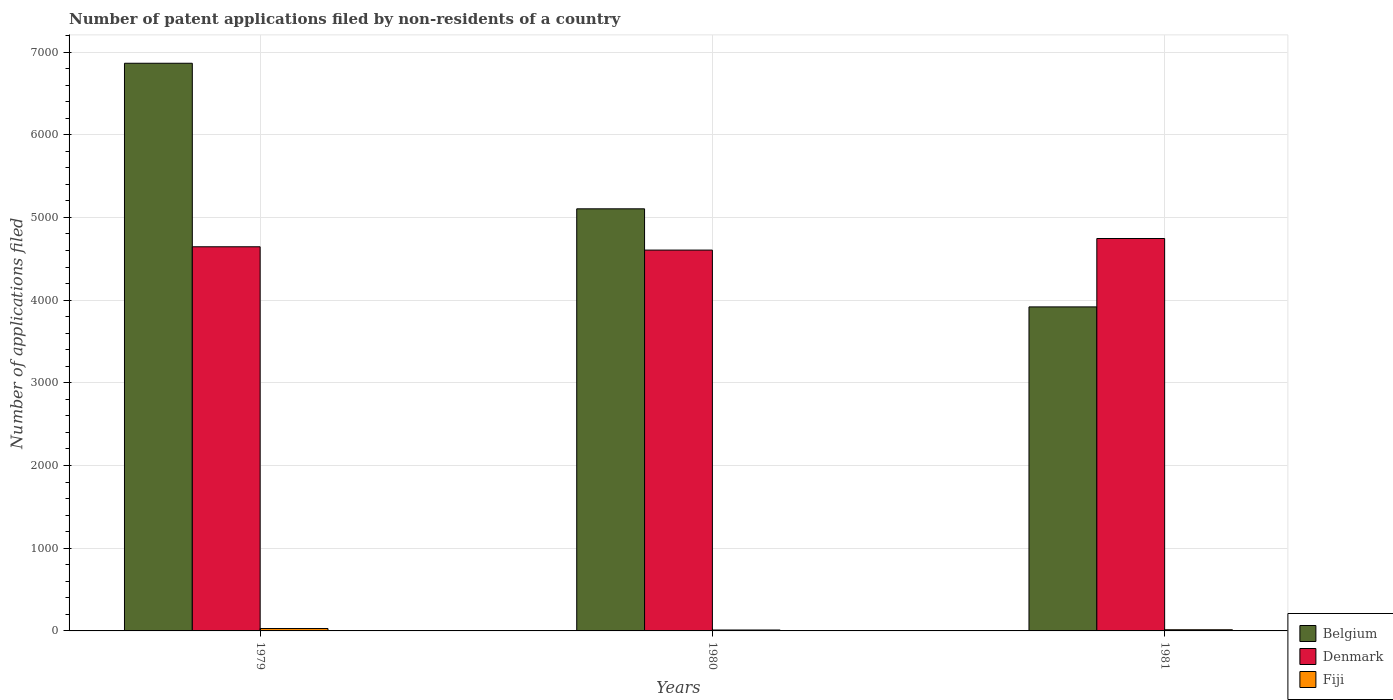How many groups of bars are there?
Offer a very short reply. 3. Are the number of bars per tick equal to the number of legend labels?
Offer a terse response. Yes. Are the number of bars on each tick of the X-axis equal?
Ensure brevity in your answer.  Yes. What is the number of applications filed in Fiji in 1979?
Make the answer very short. 29. Across all years, what is the maximum number of applications filed in Denmark?
Your answer should be very brief. 4745. Across all years, what is the minimum number of applications filed in Denmark?
Your answer should be very brief. 4605. In which year was the number of applications filed in Fiji maximum?
Keep it short and to the point. 1979. In which year was the number of applications filed in Fiji minimum?
Your response must be concise. 1980. What is the total number of applications filed in Denmark in the graph?
Offer a very short reply. 1.40e+04. What is the difference between the number of applications filed in Denmark in 1979 and that in 1980?
Make the answer very short. 40. What is the difference between the number of applications filed in Denmark in 1981 and the number of applications filed in Belgium in 1979?
Ensure brevity in your answer.  -2119. What is the average number of applications filed in Fiji per year?
Provide a succinct answer. 18. In the year 1981, what is the difference between the number of applications filed in Belgium and number of applications filed in Fiji?
Provide a succinct answer. 3904. What is the ratio of the number of applications filed in Fiji in 1979 to that in 1980?
Offer a very short reply. 2.64. Is the difference between the number of applications filed in Belgium in 1979 and 1981 greater than the difference between the number of applications filed in Fiji in 1979 and 1981?
Provide a succinct answer. Yes. What is the difference between the highest and the second highest number of applications filed in Belgium?
Your response must be concise. 1760. What is the difference between the highest and the lowest number of applications filed in Denmark?
Your response must be concise. 140. Is the sum of the number of applications filed in Denmark in 1980 and 1981 greater than the maximum number of applications filed in Belgium across all years?
Offer a very short reply. Yes. What does the 3rd bar from the left in 1979 represents?
Your response must be concise. Fiji. What does the 1st bar from the right in 1979 represents?
Your answer should be very brief. Fiji. Is it the case that in every year, the sum of the number of applications filed in Fiji and number of applications filed in Denmark is greater than the number of applications filed in Belgium?
Keep it short and to the point. No. How many bars are there?
Offer a terse response. 9. How many years are there in the graph?
Ensure brevity in your answer.  3. What is the difference between two consecutive major ticks on the Y-axis?
Your response must be concise. 1000. Does the graph contain any zero values?
Provide a succinct answer. No. Where does the legend appear in the graph?
Make the answer very short. Bottom right. How many legend labels are there?
Provide a succinct answer. 3. What is the title of the graph?
Provide a succinct answer. Number of patent applications filed by non-residents of a country. Does "Timor-Leste" appear as one of the legend labels in the graph?
Provide a succinct answer. No. What is the label or title of the Y-axis?
Your response must be concise. Number of applications filed. What is the Number of applications filed in Belgium in 1979?
Offer a terse response. 6864. What is the Number of applications filed in Denmark in 1979?
Make the answer very short. 4645. What is the Number of applications filed in Belgium in 1980?
Ensure brevity in your answer.  5104. What is the Number of applications filed of Denmark in 1980?
Give a very brief answer. 4605. What is the Number of applications filed of Belgium in 1981?
Your response must be concise. 3918. What is the Number of applications filed in Denmark in 1981?
Your response must be concise. 4745. Across all years, what is the maximum Number of applications filed of Belgium?
Keep it short and to the point. 6864. Across all years, what is the maximum Number of applications filed in Denmark?
Your response must be concise. 4745. Across all years, what is the maximum Number of applications filed in Fiji?
Ensure brevity in your answer.  29. Across all years, what is the minimum Number of applications filed in Belgium?
Offer a very short reply. 3918. Across all years, what is the minimum Number of applications filed in Denmark?
Keep it short and to the point. 4605. Across all years, what is the minimum Number of applications filed of Fiji?
Your answer should be compact. 11. What is the total Number of applications filed of Belgium in the graph?
Ensure brevity in your answer.  1.59e+04. What is the total Number of applications filed in Denmark in the graph?
Provide a succinct answer. 1.40e+04. What is the difference between the Number of applications filed in Belgium in 1979 and that in 1980?
Your answer should be very brief. 1760. What is the difference between the Number of applications filed of Belgium in 1979 and that in 1981?
Offer a terse response. 2946. What is the difference between the Number of applications filed in Denmark in 1979 and that in 1981?
Your response must be concise. -100. What is the difference between the Number of applications filed in Fiji in 1979 and that in 1981?
Offer a very short reply. 15. What is the difference between the Number of applications filed of Belgium in 1980 and that in 1981?
Your response must be concise. 1186. What is the difference between the Number of applications filed in Denmark in 1980 and that in 1981?
Provide a short and direct response. -140. What is the difference between the Number of applications filed in Fiji in 1980 and that in 1981?
Provide a succinct answer. -3. What is the difference between the Number of applications filed of Belgium in 1979 and the Number of applications filed of Denmark in 1980?
Give a very brief answer. 2259. What is the difference between the Number of applications filed of Belgium in 1979 and the Number of applications filed of Fiji in 1980?
Keep it short and to the point. 6853. What is the difference between the Number of applications filed of Denmark in 1979 and the Number of applications filed of Fiji in 1980?
Provide a short and direct response. 4634. What is the difference between the Number of applications filed of Belgium in 1979 and the Number of applications filed of Denmark in 1981?
Provide a short and direct response. 2119. What is the difference between the Number of applications filed in Belgium in 1979 and the Number of applications filed in Fiji in 1981?
Your answer should be compact. 6850. What is the difference between the Number of applications filed of Denmark in 1979 and the Number of applications filed of Fiji in 1981?
Offer a very short reply. 4631. What is the difference between the Number of applications filed of Belgium in 1980 and the Number of applications filed of Denmark in 1981?
Your answer should be compact. 359. What is the difference between the Number of applications filed in Belgium in 1980 and the Number of applications filed in Fiji in 1981?
Make the answer very short. 5090. What is the difference between the Number of applications filed in Denmark in 1980 and the Number of applications filed in Fiji in 1981?
Make the answer very short. 4591. What is the average Number of applications filed of Belgium per year?
Make the answer very short. 5295.33. What is the average Number of applications filed of Denmark per year?
Keep it short and to the point. 4665. What is the average Number of applications filed in Fiji per year?
Offer a terse response. 18. In the year 1979, what is the difference between the Number of applications filed in Belgium and Number of applications filed in Denmark?
Provide a succinct answer. 2219. In the year 1979, what is the difference between the Number of applications filed of Belgium and Number of applications filed of Fiji?
Keep it short and to the point. 6835. In the year 1979, what is the difference between the Number of applications filed of Denmark and Number of applications filed of Fiji?
Ensure brevity in your answer.  4616. In the year 1980, what is the difference between the Number of applications filed in Belgium and Number of applications filed in Denmark?
Offer a very short reply. 499. In the year 1980, what is the difference between the Number of applications filed of Belgium and Number of applications filed of Fiji?
Offer a terse response. 5093. In the year 1980, what is the difference between the Number of applications filed of Denmark and Number of applications filed of Fiji?
Make the answer very short. 4594. In the year 1981, what is the difference between the Number of applications filed in Belgium and Number of applications filed in Denmark?
Your answer should be compact. -827. In the year 1981, what is the difference between the Number of applications filed of Belgium and Number of applications filed of Fiji?
Ensure brevity in your answer.  3904. In the year 1981, what is the difference between the Number of applications filed of Denmark and Number of applications filed of Fiji?
Offer a terse response. 4731. What is the ratio of the Number of applications filed of Belgium in 1979 to that in 1980?
Your answer should be very brief. 1.34. What is the ratio of the Number of applications filed of Denmark in 1979 to that in 1980?
Provide a succinct answer. 1.01. What is the ratio of the Number of applications filed of Fiji in 1979 to that in 1980?
Provide a short and direct response. 2.64. What is the ratio of the Number of applications filed of Belgium in 1979 to that in 1981?
Offer a very short reply. 1.75. What is the ratio of the Number of applications filed of Denmark in 1979 to that in 1981?
Provide a succinct answer. 0.98. What is the ratio of the Number of applications filed of Fiji in 1979 to that in 1981?
Your answer should be compact. 2.07. What is the ratio of the Number of applications filed of Belgium in 1980 to that in 1981?
Your answer should be very brief. 1.3. What is the ratio of the Number of applications filed of Denmark in 1980 to that in 1981?
Provide a short and direct response. 0.97. What is the ratio of the Number of applications filed of Fiji in 1980 to that in 1981?
Keep it short and to the point. 0.79. What is the difference between the highest and the second highest Number of applications filed in Belgium?
Your answer should be compact. 1760. What is the difference between the highest and the second highest Number of applications filed in Fiji?
Your answer should be compact. 15. What is the difference between the highest and the lowest Number of applications filed of Belgium?
Your answer should be compact. 2946. What is the difference between the highest and the lowest Number of applications filed of Denmark?
Your answer should be compact. 140. What is the difference between the highest and the lowest Number of applications filed of Fiji?
Keep it short and to the point. 18. 